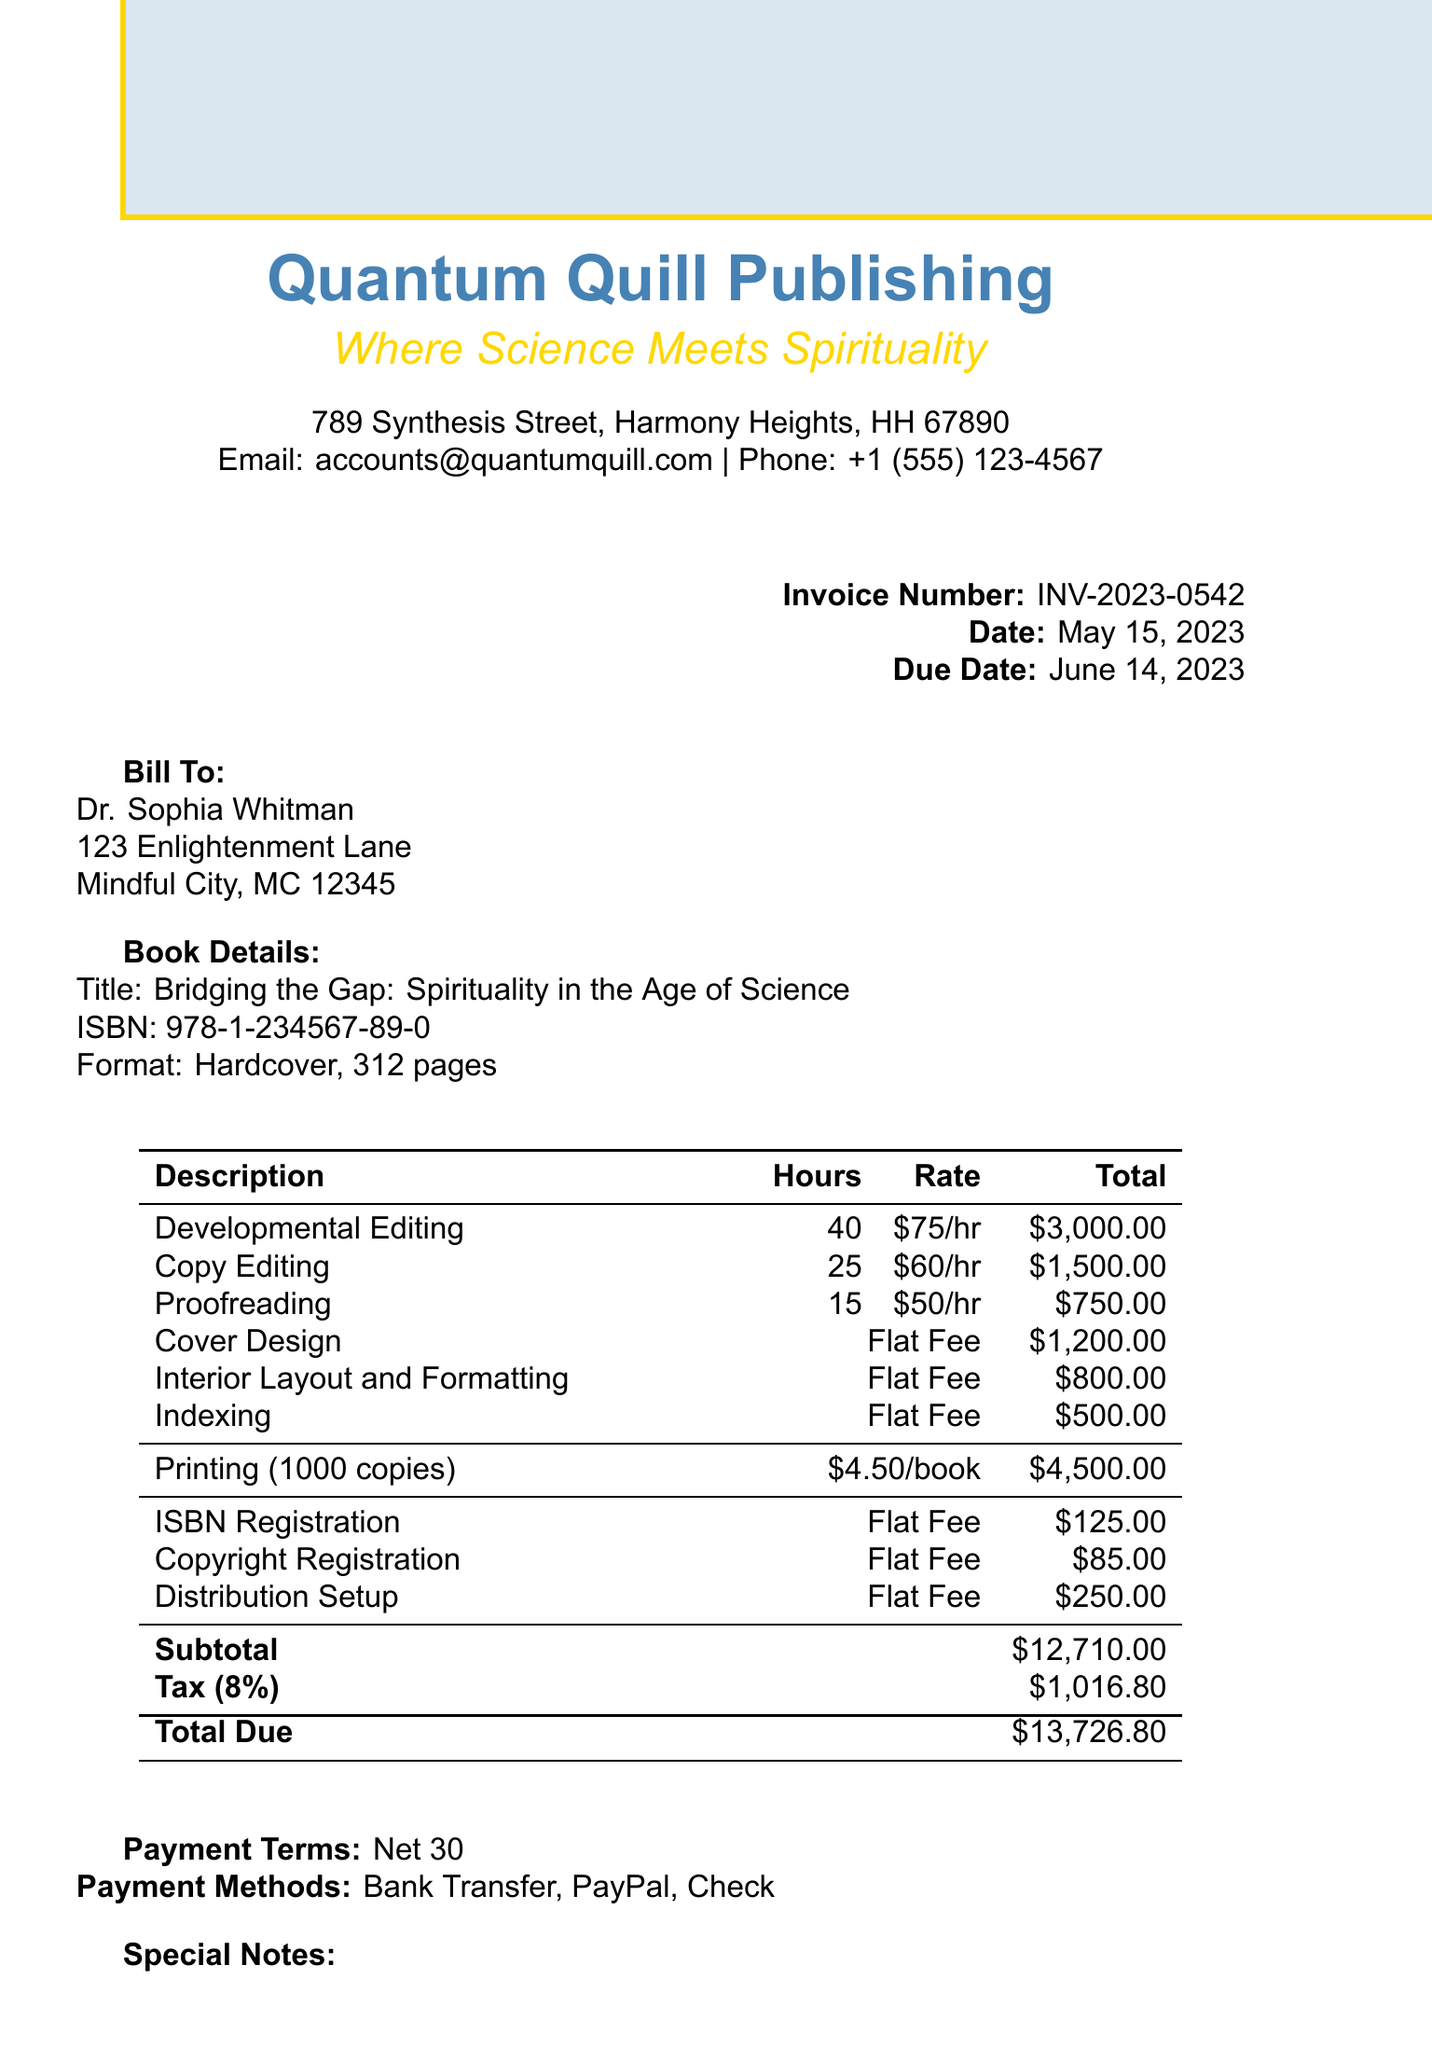What is the invoice number? The invoice number is a unique identifier for this document, which is specified in the header section.
Answer: INV-2023-0542 Who is the author of the book? The author's name is provided in the billing information section of the invoice.
Answer: Dr. Sophia Whitman What is the total due amount? The total due amount is calculated as the sum of the subtotal and tax amount listed at the bottom of the invoice.
Answer: $13,726.80 What is the quantity of books printed? The quantity of books printed is mentioned in the printing details section of the invoice.
Answer: 1000 How much does cover design cost? The cost for cover design is specified along with other editing and design services in the invoice.
Answer: $1,200.00 What is the payment term? The payment terms indicate the period within which payment should be made, as stated in the invoice.
Answer: Net 30 Which email address is associated with the publisher? The invoice provides contact information for the publisher, including their email address.
Answer: accounts@quantumquill.com What is the tax rate applied to the invoice? The tax rate is clearly stated in the invoice under the billing details, showing what percentage is applied to the subtotal.
Answer: 8% What services are included under additional services? The invoice lists several additional services apart from the main services, showing a diverse range of offerings.
Answer: ISBN Registration, Copyright Registration, Distribution Setup 